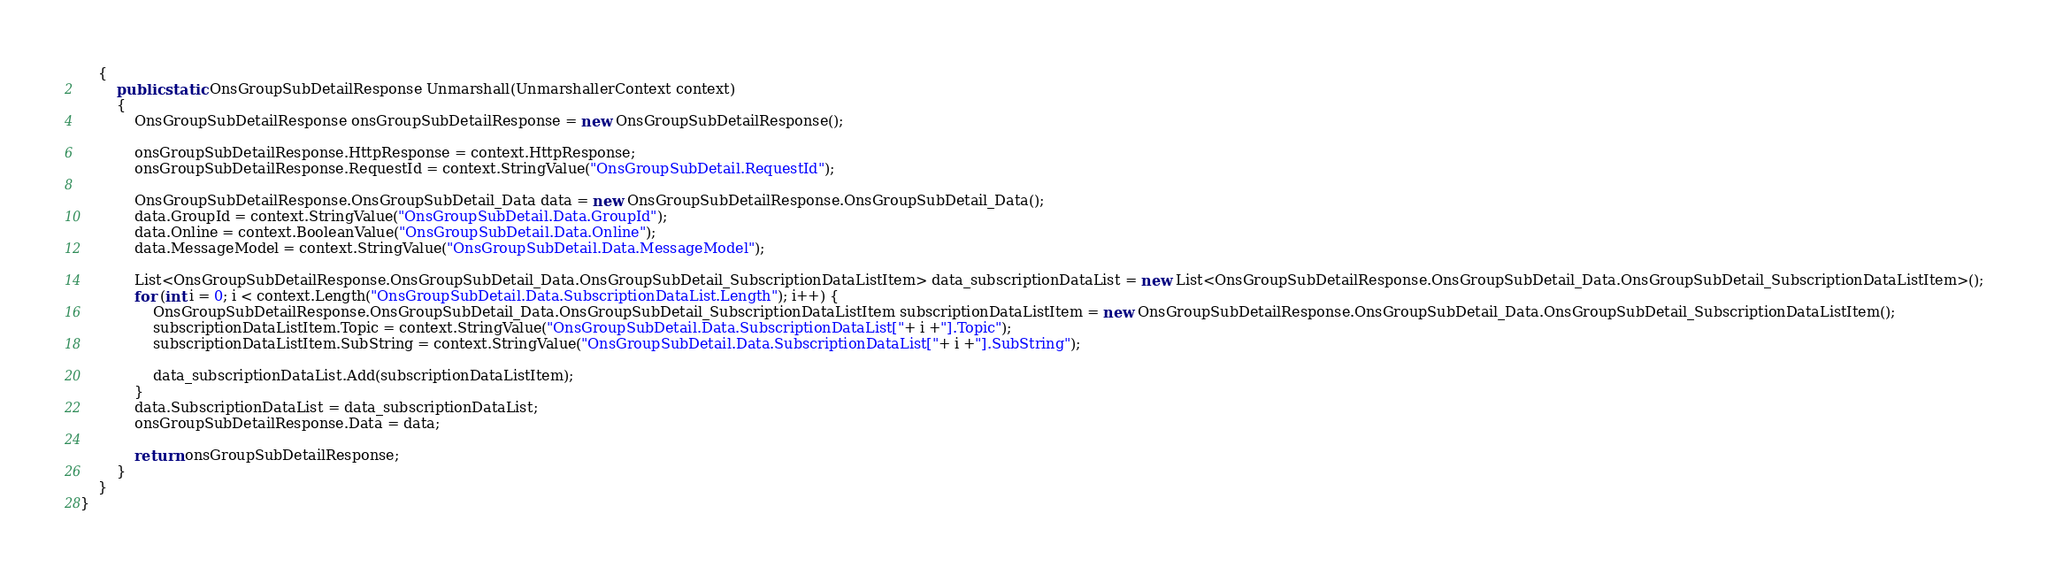<code> <loc_0><loc_0><loc_500><loc_500><_C#_>    {
        public static OnsGroupSubDetailResponse Unmarshall(UnmarshallerContext context)
        {
			OnsGroupSubDetailResponse onsGroupSubDetailResponse = new OnsGroupSubDetailResponse();

			onsGroupSubDetailResponse.HttpResponse = context.HttpResponse;
			onsGroupSubDetailResponse.RequestId = context.StringValue("OnsGroupSubDetail.RequestId");

			OnsGroupSubDetailResponse.OnsGroupSubDetail_Data data = new OnsGroupSubDetailResponse.OnsGroupSubDetail_Data();
			data.GroupId = context.StringValue("OnsGroupSubDetail.Data.GroupId");
			data.Online = context.BooleanValue("OnsGroupSubDetail.Data.Online");
			data.MessageModel = context.StringValue("OnsGroupSubDetail.Data.MessageModel");

			List<OnsGroupSubDetailResponse.OnsGroupSubDetail_Data.OnsGroupSubDetail_SubscriptionDataListItem> data_subscriptionDataList = new List<OnsGroupSubDetailResponse.OnsGroupSubDetail_Data.OnsGroupSubDetail_SubscriptionDataListItem>();
			for (int i = 0; i < context.Length("OnsGroupSubDetail.Data.SubscriptionDataList.Length"); i++) {
				OnsGroupSubDetailResponse.OnsGroupSubDetail_Data.OnsGroupSubDetail_SubscriptionDataListItem subscriptionDataListItem = new OnsGroupSubDetailResponse.OnsGroupSubDetail_Data.OnsGroupSubDetail_SubscriptionDataListItem();
				subscriptionDataListItem.Topic = context.StringValue("OnsGroupSubDetail.Data.SubscriptionDataList["+ i +"].Topic");
				subscriptionDataListItem.SubString = context.StringValue("OnsGroupSubDetail.Data.SubscriptionDataList["+ i +"].SubString");

				data_subscriptionDataList.Add(subscriptionDataListItem);
			}
			data.SubscriptionDataList = data_subscriptionDataList;
			onsGroupSubDetailResponse.Data = data;
        
			return onsGroupSubDetailResponse;
        }
    }
}
</code> 